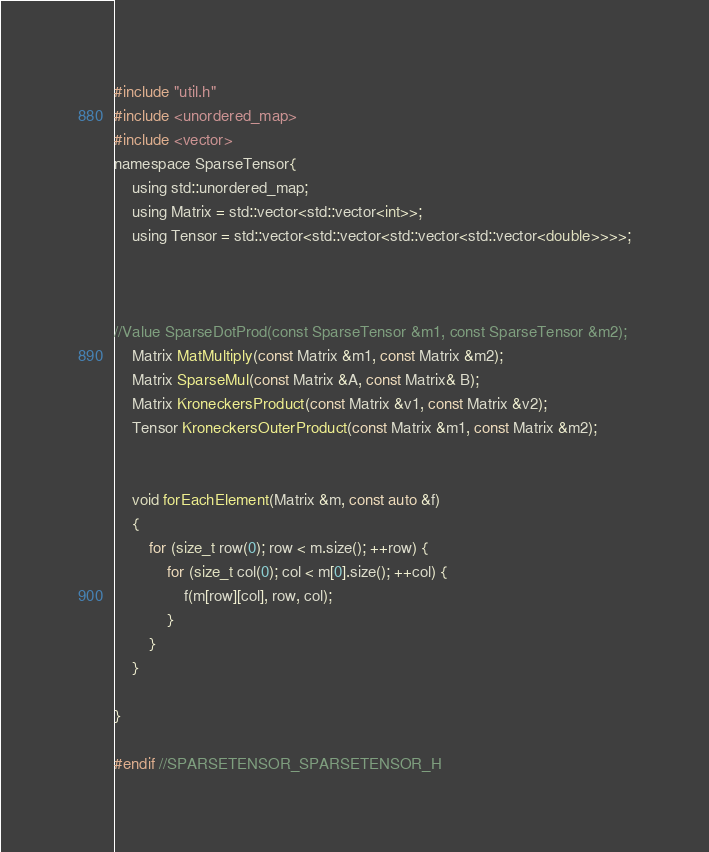Convert code to text. <code><loc_0><loc_0><loc_500><loc_500><_C_>#include "util.h"
#include <unordered_map>
#include <vector>
namespace SparseTensor{
    using std::unordered_map;
    using Matrix = std::vector<std::vector<int>>;
    using Tensor = std::vector<std::vector<std::vector<std::vector<double>>>>;



//Value SparseDotProd(const SparseTensor &m1, const SparseTensor &m2);
    Matrix MatMultiply(const Matrix &m1, const Matrix &m2);
    Matrix SparseMul(const Matrix &A, const Matrix& B);
    Matrix KroneckersProduct(const Matrix &v1, const Matrix &v2);
    Tensor KroneckersOuterProduct(const Matrix &m1, const Matrix &m2);


    void forEachElement(Matrix &m, const auto &f)
    {
        for (size_t row(0); row < m.size(); ++row) {
            for (size_t col(0); col < m[0].size(); ++col) {
                f(m[row][col], row, col);
            }
        }
    }

}

#endif //SPARSETENSOR_SPARSETENSOR_H
</code> 